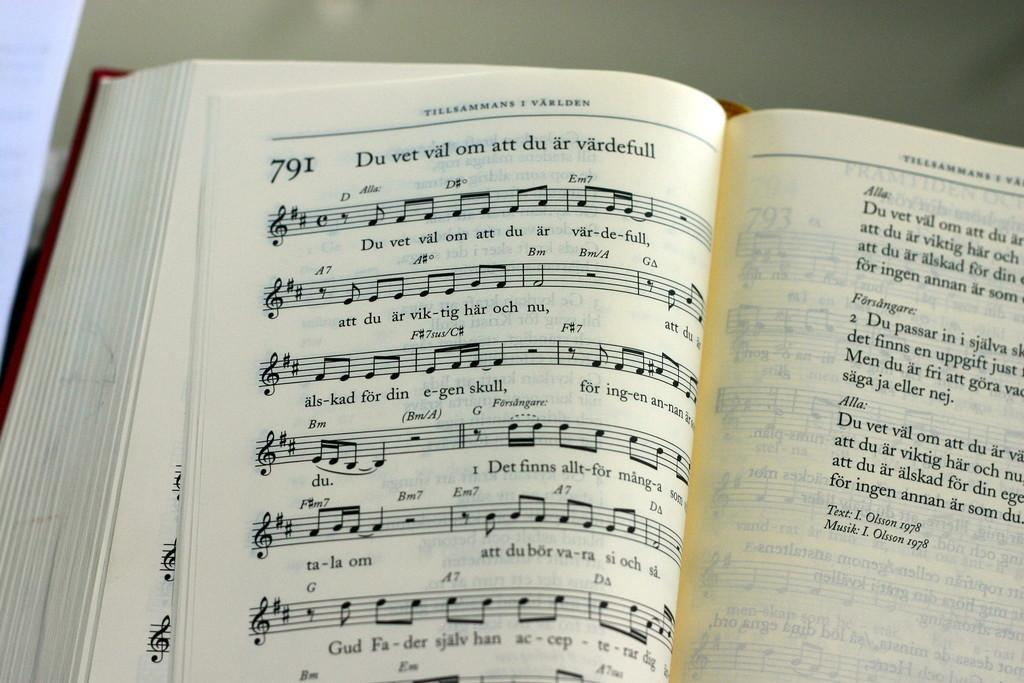<image>
Provide a brief description of the given image. An open hymn book featuring a hymn on the page called "Du Vet Val om att du ar vardefull." 